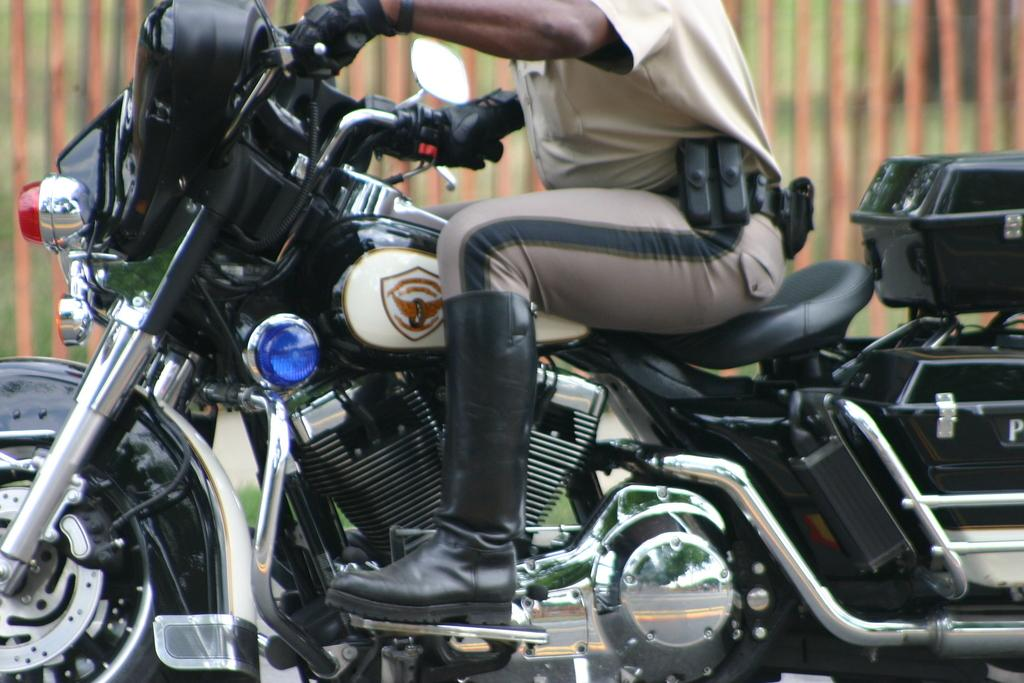What is the main subject of the image? There is a person in the image. What is the person wearing on their hands? The person is wearing gloves. What is the person wearing on their feet? The person is wearing shoes. What type of vehicle is the person sitting on? The person is sitting on a motorbike. What additional item is present on the motorbike? There is a luggage box in the image. What type of terrain is visible in the image? Grass is visible in the image. What objects made of wood are present in the image? Wooden sticks are present in the image. How would you describe the background of the image? The background of the image is blurry. What type of humor can be heard coming from the person in the image? There is no indication of humor or any sounds in the image, so it's not possible to determine what type of humor might be heard. 